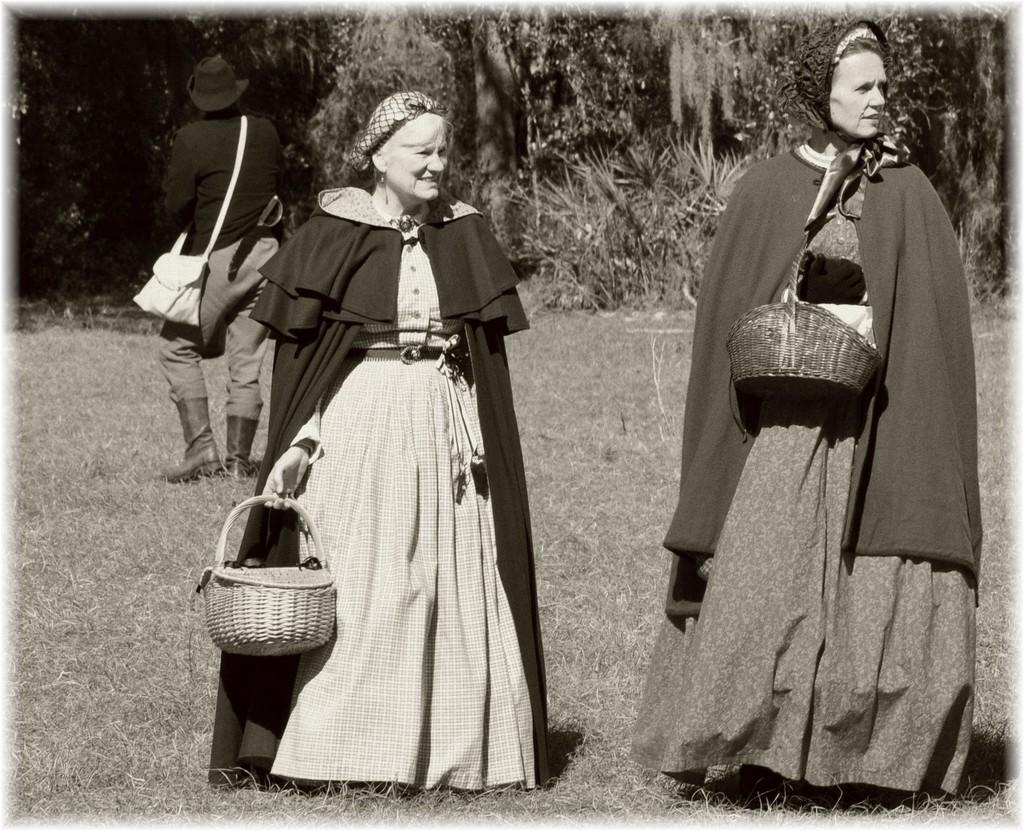How many women are in the image? There are two women standing in the image. Can you describe the background of the image? There is a person standing in the background of the image. What type of terrain is visible in the image? Grass is present on the ground, and there are trees visible in the image. What type of key is being used to unlock the order in the image? There is no key or order present in the image; it features two women and a person in the background, with grass and trees visible. 